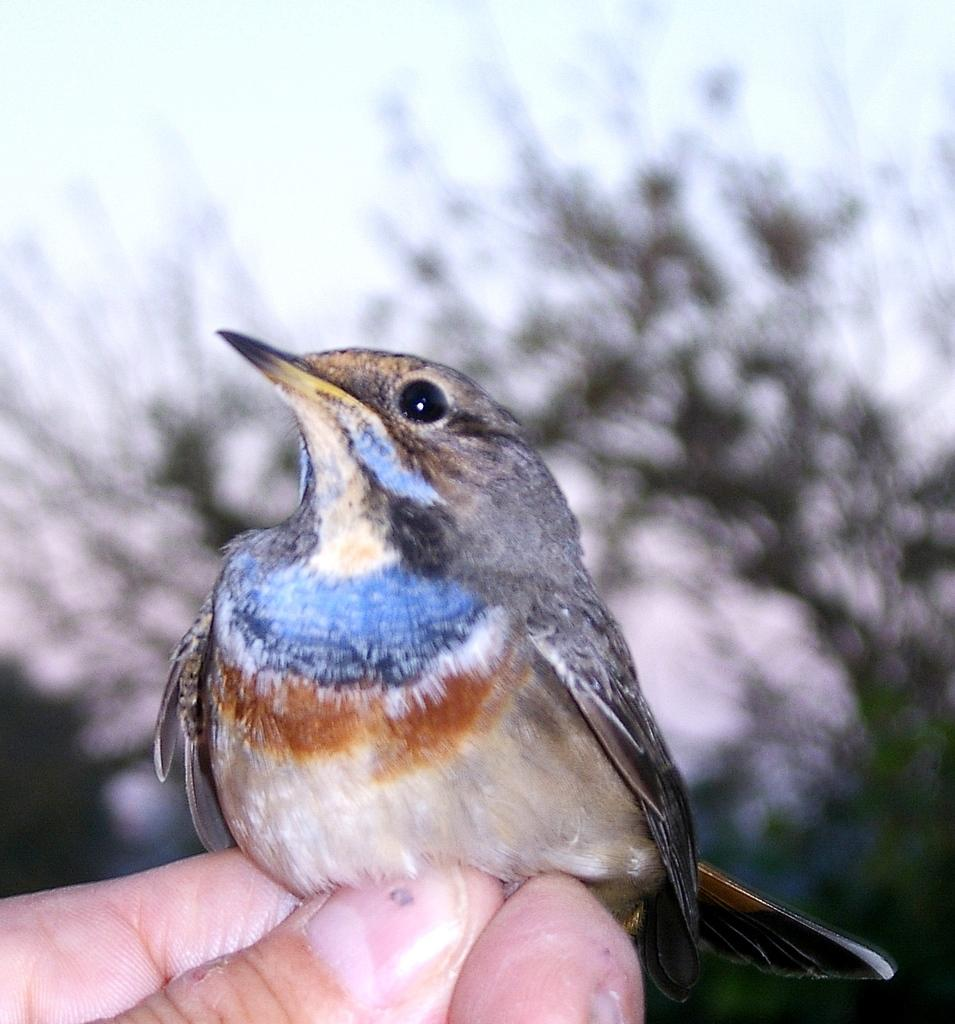Who or what is the main subject in the image? There is a person in the image. What is the person holding in the image? The person is holding a bird. What can be seen in the background of the image? There is a tree and the sky visible in the image. Can you describe the bird's appearance? The bird has blue, orange, brown, and cream colors. What type of riddle is the person solving in the image? There is no riddle present in the image; it features a person holding a bird. Can you tell me how many grapes are on the tree in the image? There are no grapes visible in the image; only a tree is present in the background. 